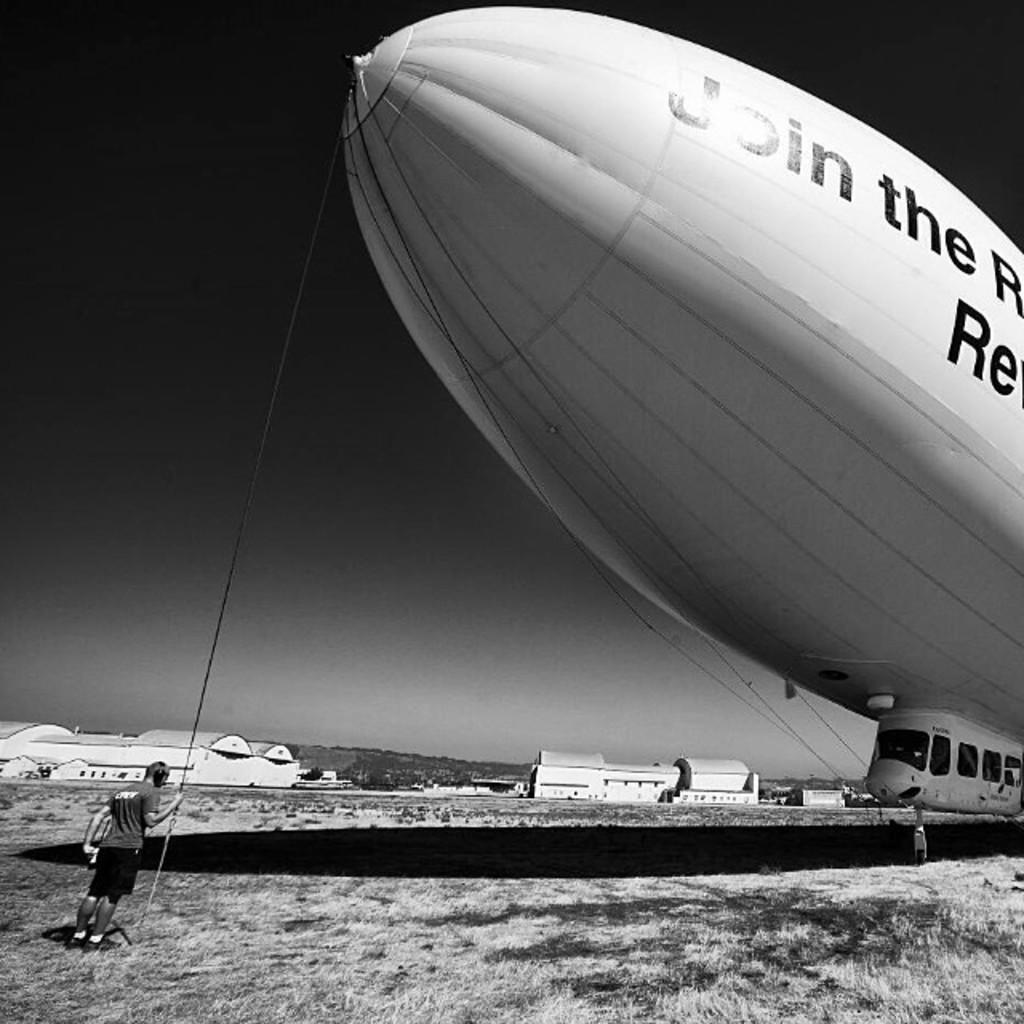What is the main subject of the image? The main subject of the image is an airship. What can be seen on the airship? Something is written on the airship. How is the airship connected to the ground? There is a rope attached to the airship. Who is holding the rope? A person is holding the rope. What can be seen in the background of the image? There are buildings and the sky visible in the background of the image. What type of ship is sailing in the ocean in the image? There is no ship sailing in the ocean in the image; it features an airship. What team is responsible for operating the airship in the image? There is no team operating the airship in the image; it is not mentioned in the provided facts. 